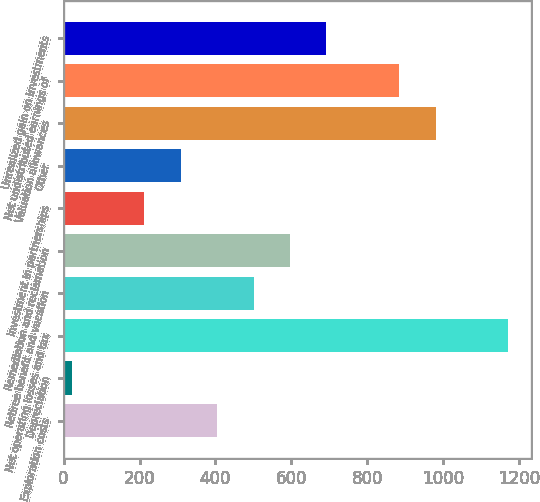Convert chart to OTSL. <chart><loc_0><loc_0><loc_500><loc_500><bar_chart><fcel>Exploration costs<fcel>Depreciation<fcel>Net operating losses and tax<fcel>Retiree benefit and vacation<fcel>Remediation and reclamation<fcel>Investment in partnerships<fcel>Other<fcel>Valuation allowances<fcel>Net undistributed earnings of<fcel>Unrealized gain on investments<nl><fcel>404.6<fcel>21<fcel>1171.8<fcel>500.5<fcel>596.4<fcel>212.8<fcel>308.7<fcel>980<fcel>884.1<fcel>692.3<nl></chart> 